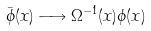<formula> <loc_0><loc_0><loc_500><loc_500>\bar { \phi } ( x ) \longrightarrow \Omega ^ { - 1 } ( x ) \phi ( x )</formula> 